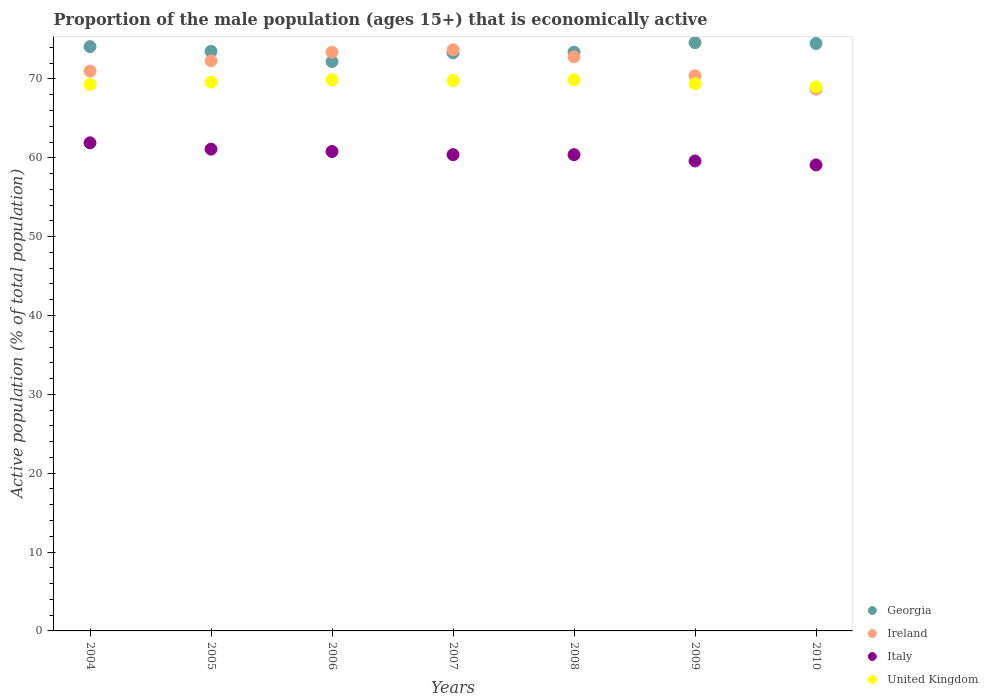How many different coloured dotlines are there?
Provide a succinct answer. 4. What is the proportion of the male population that is economically active in Italy in 2009?
Keep it short and to the point. 59.6. Across all years, what is the maximum proportion of the male population that is economically active in Italy?
Keep it short and to the point. 61.9. Across all years, what is the minimum proportion of the male population that is economically active in United Kingdom?
Offer a terse response. 69. What is the total proportion of the male population that is economically active in Italy in the graph?
Provide a short and direct response. 423.3. What is the difference between the proportion of the male population that is economically active in Georgia in 2010 and the proportion of the male population that is economically active in Ireland in 2008?
Offer a terse response. 1.7. What is the average proportion of the male population that is economically active in United Kingdom per year?
Keep it short and to the point. 69.56. In the year 2004, what is the difference between the proportion of the male population that is economically active in Ireland and proportion of the male population that is economically active in United Kingdom?
Offer a very short reply. 1.7. What is the ratio of the proportion of the male population that is economically active in United Kingdom in 2007 to that in 2008?
Make the answer very short. 1. Is the proportion of the male population that is economically active in Italy in 2005 less than that in 2009?
Ensure brevity in your answer.  No. Is the difference between the proportion of the male population that is economically active in Ireland in 2007 and 2009 greater than the difference between the proportion of the male population that is economically active in United Kingdom in 2007 and 2009?
Your answer should be compact. Yes. What is the difference between the highest and the lowest proportion of the male population that is economically active in Georgia?
Provide a succinct answer. 2.4. Is the sum of the proportion of the male population that is economically active in Georgia in 2006 and 2007 greater than the maximum proportion of the male population that is economically active in Italy across all years?
Give a very brief answer. Yes. Is it the case that in every year, the sum of the proportion of the male population that is economically active in United Kingdom and proportion of the male population that is economically active in Georgia  is greater than the sum of proportion of the male population that is economically active in Italy and proportion of the male population that is economically active in Ireland?
Your response must be concise. Yes. Is it the case that in every year, the sum of the proportion of the male population that is economically active in Ireland and proportion of the male population that is economically active in Georgia  is greater than the proportion of the male population that is economically active in Italy?
Provide a short and direct response. Yes. Does the proportion of the male population that is economically active in United Kingdom monotonically increase over the years?
Your response must be concise. No. Is the proportion of the male population that is economically active in United Kingdom strictly less than the proportion of the male population that is economically active in Ireland over the years?
Keep it short and to the point. No. Does the graph contain grids?
Provide a succinct answer. No. Where does the legend appear in the graph?
Provide a short and direct response. Bottom right. How are the legend labels stacked?
Give a very brief answer. Vertical. What is the title of the graph?
Keep it short and to the point. Proportion of the male population (ages 15+) that is economically active. What is the label or title of the X-axis?
Provide a short and direct response. Years. What is the label or title of the Y-axis?
Make the answer very short. Active population (% of total population). What is the Active population (% of total population) of Georgia in 2004?
Make the answer very short. 74.1. What is the Active population (% of total population) of Italy in 2004?
Provide a short and direct response. 61.9. What is the Active population (% of total population) in United Kingdom in 2004?
Make the answer very short. 69.3. What is the Active population (% of total population) of Georgia in 2005?
Keep it short and to the point. 73.5. What is the Active population (% of total population) of Ireland in 2005?
Your response must be concise. 72.3. What is the Active population (% of total population) of Italy in 2005?
Offer a very short reply. 61.1. What is the Active population (% of total population) of United Kingdom in 2005?
Offer a very short reply. 69.6. What is the Active population (% of total population) in Georgia in 2006?
Make the answer very short. 72.2. What is the Active population (% of total population) in Ireland in 2006?
Provide a succinct answer. 73.4. What is the Active population (% of total population) of Italy in 2006?
Give a very brief answer. 60.8. What is the Active population (% of total population) in United Kingdom in 2006?
Your answer should be compact. 69.9. What is the Active population (% of total population) in Georgia in 2007?
Your answer should be compact. 73.3. What is the Active population (% of total population) in Ireland in 2007?
Provide a succinct answer. 73.7. What is the Active population (% of total population) of Italy in 2007?
Ensure brevity in your answer.  60.4. What is the Active population (% of total population) in United Kingdom in 2007?
Your answer should be compact. 69.8. What is the Active population (% of total population) of Georgia in 2008?
Give a very brief answer. 73.4. What is the Active population (% of total population) in Ireland in 2008?
Provide a short and direct response. 72.8. What is the Active population (% of total population) of Italy in 2008?
Ensure brevity in your answer.  60.4. What is the Active population (% of total population) in United Kingdom in 2008?
Make the answer very short. 69.9. What is the Active population (% of total population) of Georgia in 2009?
Your answer should be very brief. 74.6. What is the Active population (% of total population) of Ireland in 2009?
Give a very brief answer. 70.4. What is the Active population (% of total population) in Italy in 2009?
Offer a very short reply. 59.6. What is the Active population (% of total population) in United Kingdom in 2009?
Offer a very short reply. 69.4. What is the Active population (% of total population) of Georgia in 2010?
Your response must be concise. 74.5. What is the Active population (% of total population) in Ireland in 2010?
Offer a terse response. 68.7. What is the Active population (% of total population) of Italy in 2010?
Offer a terse response. 59.1. Across all years, what is the maximum Active population (% of total population) of Georgia?
Your answer should be compact. 74.6. Across all years, what is the maximum Active population (% of total population) in Ireland?
Your answer should be compact. 73.7. Across all years, what is the maximum Active population (% of total population) in Italy?
Make the answer very short. 61.9. Across all years, what is the maximum Active population (% of total population) of United Kingdom?
Keep it short and to the point. 69.9. Across all years, what is the minimum Active population (% of total population) of Georgia?
Keep it short and to the point. 72.2. Across all years, what is the minimum Active population (% of total population) in Ireland?
Your response must be concise. 68.7. Across all years, what is the minimum Active population (% of total population) of Italy?
Ensure brevity in your answer.  59.1. What is the total Active population (% of total population) of Georgia in the graph?
Your answer should be compact. 515.6. What is the total Active population (% of total population) in Ireland in the graph?
Ensure brevity in your answer.  502.3. What is the total Active population (% of total population) in Italy in the graph?
Provide a succinct answer. 423.3. What is the total Active population (% of total population) in United Kingdom in the graph?
Ensure brevity in your answer.  486.9. What is the difference between the Active population (% of total population) of United Kingdom in 2004 and that in 2005?
Keep it short and to the point. -0.3. What is the difference between the Active population (% of total population) in Ireland in 2004 and that in 2006?
Give a very brief answer. -2.4. What is the difference between the Active population (% of total population) of Italy in 2004 and that in 2006?
Ensure brevity in your answer.  1.1. What is the difference between the Active population (% of total population) of Georgia in 2004 and that in 2007?
Provide a short and direct response. 0.8. What is the difference between the Active population (% of total population) of Ireland in 2004 and that in 2007?
Give a very brief answer. -2.7. What is the difference between the Active population (% of total population) in Italy in 2004 and that in 2007?
Provide a short and direct response. 1.5. What is the difference between the Active population (% of total population) in Italy in 2004 and that in 2008?
Provide a short and direct response. 1.5. What is the difference between the Active population (% of total population) of United Kingdom in 2004 and that in 2008?
Your answer should be very brief. -0.6. What is the difference between the Active population (% of total population) of Georgia in 2004 and that in 2009?
Offer a terse response. -0.5. What is the difference between the Active population (% of total population) of Ireland in 2004 and that in 2009?
Offer a very short reply. 0.6. What is the difference between the Active population (% of total population) in Georgia in 2004 and that in 2010?
Keep it short and to the point. -0.4. What is the difference between the Active population (% of total population) in Ireland in 2004 and that in 2010?
Keep it short and to the point. 2.3. What is the difference between the Active population (% of total population) in United Kingdom in 2004 and that in 2010?
Ensure brevity in your answer.  0.3. What is the difference between the Active population (% of total population) in Georgia in 2005 and that in 2006?
Ensure brevity in your answer.  1.3. What is the difference between the Active population (% of total population) in Italy in 2005 and that in 2006?
Your answer should be very brief. 0.3. What is the difference between the Active population (% of total population) of Georgia in 2005 and that in 2007?
Provide a succinct answer. 0.2. What is the difference between the Active population (% of total population) of Ireland in 2005 and that in 2007?
Keep it short and to the point. -1.4. What is the difference between the Active population (% of total population) in Italy in 2005 and that in 2007?
Provide a short and direct response. 0.7. What is the difference between the Active population (% of total population) in Georgia in 2005 and that in 2008?
Keep it short and to the point. 0.1. What is the difference between the Active population (% of total population) of Ireland in 2005 and that in 2008?
Ensure brevity in your answer.  -0.5. What is the difference between the Active population (% of total population) of United Kingdom in 2005 and that in 2008?
Provide a succinct answer. -0.3. What is the difference between the Active population (% of total population) of United Kingdom in 2005 and that in 2009?
Ensure brevity in your answer.  0.2. What is the difference between the Active population (% of total population) of Georgia in 2005 and that in 2010?
Give a very brief answer. -1. What is the difference between the Active population (% of total population) in Georgia in 2006 and that in 2007?
Provide a succinct answer. -1.1. What is the difference between the Active population (% of total population) of Ireland in 2006 and that in 2007?
Offer a terse response. -0.3. What is the difference between the Active population (% of total population) in Italy in 2006 and that in 2007?
Offer a terse response. 0.4. What is the difference between the Active population (% of total population) in Georgia in 2006 and that in 2008?
Provide a succinct answer. -1.2. What is the difference between the Active population (% of total population) in Ireland in 2006 and that in 2008?
Provide a succinct answer. 0.6. What is the difference between the Active population (% of total population) in Ireland in 2006 and that in 2009?
Offer a terse response. 3. What is the difference between the Active population (% of total population) in Italy in 2006 and that in 2009?
Your answer should be compact. 1.2. What is the difference between the Active population (% of total population) in Ireland in 2006 and that in 2010?
Offer a terse response. 4.7. What is the difference between the Active population (% of total population) in Italy in 2007 and that in 2008?
Provide a short and direct response. 0. What is the difference between the Active population (% of total population) in Ireland in 2007 and that in 2009?
Make the answer very short. 3.3. What is the difference between the Active population (% of total population) in Italy in 2007 and that in 2009?
Your response must be concise. 0.8. What is the difference between the Active population (% of total population) of United Kingdom in 2007 and that in 2009?
Keep it short and to the point. 0.4. What is the difference between the Active population (% of total population) in Ireland in 2007 and that in 2010?
Your answer should be very brief. 5. What is the difference between the Active population (% of total population) in Italy in 2007 and that in 2010?
Keep it short and to the point. 1.3. What is the difference between the Active population (% of total population) in Georgia in 2008 and that in 2009?
Keep it short and to the point. -1.2. What is the difference between the Active population (% of total population) of Italy in 2008 and that in 2009?
Your answer should be compact. 0.8. What is the difference between the Active population (% of total population) of United Kingdom in 2008 and that in 2009?
Give a very brief answer. 0.5. What is the difference between the Active population (% of total population) of Georgia in 2008 and that in 2010?
Provide a short and direct response. -1.1. What is the difference between the Active population (% of total population) of Italy in 2008 and that in 2010?
Your answer should be very brief. 1.3. What is the difference between the Active population (% of total population) in Ireland in 2009 and that in 2010?
Keep it short and to the point. 1.7. What is the difference between the Active population (% of total population) in Georgia in 2004 and the Active population (% of total population) in Italy in 2005?
Your answer should be very brief. 13. What is the difference between the Active population (% of total population) of Ireland in 2004 and the Active population (% of total population) of Italy in 2005?
Make the answer very short. 9.9. What is the difference between the Active population (% of total population) in Italy in 2004 and the Active population (% of total population) in United Kingdom in 2005?
Give a very brief answer. -7.7. What is the difference between the Active population (% of total population) in Georgia in 2004 and the Active population (% of total population) in United Kingdom in 2006?
Your answer should be very brief. 4.2. What is the difference between the Active population (% of total population) in Georgia in 2004 and the Active population (% of total population) in Ireland in 2007?
Make the answer very short. 0.4. What is the difference between the Active population (% of total population) of Georgia in 2004 and the Active population (% of total population) of Italy in 2007?
Your response must be concise. 13.7. What is the difference between the Active population (% of total population) in Ireland in 2004 and the Active population (% of total population) in Italy in 2007?
Provide a succinct answer. 10.6. What is the difference between the Active population (% of total population) in Italy in 2004 and the Active population (% of total population) in United Kingdom in 2007?
Keep it short and to the point. -7.9. What is the difference between the Active population (% of total population) in Georgia in 2004 and the Active population (% of total population) in Italy in 2008?
Provide a short and direct response. 13.7. What is the difference between the Active population (% of total population) of Georgia in 2004 and the Active population (% of total population) of United Kingdom in 2008?
Keep it short and to the point. 4.2. What is the difference between the Active population (% of total population) in Ireland in 2004 and the Active population (% of total population) in United Kingdom in 2008?
Make the answer very short. 1.1. What is the difference between the Active population (% of total population) of Georgia in 2004 and the Active population (% of total population) of Italy in 2009?
Offer a terse response. 14.5. What is the difference between the Active population (% of total population) of Italy in 2004 and the Active population (% of total population) of United Kingdom in 2009?
Provide a succinct answer. -7.5. What is the difference between the Active population (% of total population) of Georgia in 2004 and the Active population (% of total population) of United Kingdom in 2010?
Provide a short and direct response. 5.1. What is the difference between the Active population (% of total population) of Ireland in 2004 and the Active population (% of total population) of Italy in 2010?
Ensure brevity in your answer.  11.9. What is the difference between the Active population (% of total population) of Ireland in 2004 and the Active population (% of total population) of United Kingdom in 2010?
Offer a terse response. 2. What is the difference between the Active population (% of total population) in Ireland in 2005 and the Active population (% of total population) in Italy in 2006?
Ensure brevity in your answer.  11.5. What is the difference between the Active population (% of total population) in Ireland in 2005 and the Active population (% of total population) in United Kingdom in 2006?
Provide a succinct answer. 2.4. What is the difference between the Active population (% of total population) of Georgia in 2005 and the Active population (% of total population) of Italy in 2007?
Give a very brief answer. 13.1. What is the difference between the Active population (% of total population) of Ireland in 2005 and the Active population (% of total population) of Italy in 2007?
Ensure brevity in your answer.  11.9. What is the difference between the Active population (% of total population) of Italy in 2005 and the Active population (% of total population) of United Kingdom in 2007?
Keep it short and to the point. -8.7. What is the difference between the Active population (% of total population) in Georgia in 2005 and the Active population (% of total population) in Ireland in 2008?
Your answer should be very brief. 0.7. What is the difference between the Active population (% of total population) in Georgia in 2005 and the Active population (% of total population) in Italy in 2008?
Offer a very short reply. 13.1. What is the difference between the Active population (% of total population) of Georgia in 2005 and the Active population (% of total population) of United Kingdom in 2008?
Provide a succinct answer. 3.6. What is the difference between the Active population (% of total population) of Ireland in 2005 and the Active population (% of total population) of Italy in 2008?
Keep it short and to the point. 11.9. What is the difference between the Active population (% of total population) of Ireland in 2005 and the Active population (% of total population) of Italy in 2009?
Give a very brief answer. 12.7. What is the difference between the Active population (% of total population) in Ireland in 2005 and the Active population (% of total population) in United Kingdom in 2009?
Provide a succinct answer. 2.9. What is the difference between the Active population (% of total population) of Italy in 2005 and the Active population (% of total population) of United Kingdom in 2009?
Your answer should be very brief. -8.3. What is the difference between the Active population (% of total population) of Georgia in 2005 and the Active population (% of total population) of Ireland in 2010?
Keep it short and to the point. 4.8. What is the difference between the Active population (% of total population) of Ireland in 2005 and the Active population (% of total population) of Italy in 2010?
Your response must be concise. 13.2. What is the difference between the Active population (% of total population) in Italy in 2005 and the Active population (% of total population) in United Kingdom in 2010?
Provide a succinct answer. -7.9. What is the difference between the Active population (% of total population) in Georgia in 2006 and the Active population (% of total population) in Italy in 2007?
Offer a terse response. 11.8. What is the difference between the Active population (% of total population) in Ireland in 2006 and the Active population (% of total population) in Italy in 2007?
Offer a very short reply. 13. What is the difference between the Active population (% of total population) of Ireland in 2006 and the Active population (% of total population) of United Kingdom in 2007?
Provide a short and direct response. 3.6. What is the difference between the Active population (% of total population) in Georgia in 2006 and the Active population (% of total population) in Italy in 2008?
Your answer should be very brief. 11.8. What is the difference between the Active population (% of total population) in Georgia in 2006 and the Active population (% of total population) in United Kingdom in 2008?
Offer a very short reply. 2.3. What is the difference between the Active population (% of total population) of Ireland in 2006 and the Active population (% of total population) of United Kingdom in 2008?
Offer a very short reply. 3.5. What is the difference between the Active population (% of total population) in Italy in 2006 and the Active population (% of total population) in United Kingdom in 2009?
Keep it short and to the point. -8.6. What is the difference between the Active population (% of total population) in Ireland in 2006 and the Active population (% of total population) in United Kingdom in 2010?
Make the answer very short. 4.4. What is the difference between the Active population (% of total population) in Italy in 2006 and the Active population (% of total population) in United Kingdom in 2010?
Your response must be concise. -8.2. What is the difference between the Active population (% of total population) in Georgia in 2007 and the Active population (% of total population) in Ireland in 2008?
Make the answer very short. 0.5. What is the difference between the Active population (% of total population) in Georgia in 2007 and the Active population (% of total population) in United Kingdom in 2009?
Offer a terse response. 3.9. What is the difference between the Active population (% of total population) of Ireland in 2007 and the Active population (% of total population) of United Kingdom in 2009?
Make the answer very short. 4.3. What is the difference between the Active population (% of total population) of Italy in 2007 and the Active population (% of total population) of United Kingdom in 2009?
Provide a succinct answer. -9. What is the difference between the Active population (% of total population) of Georgia in 2007 and the Active population (% of total population) of Ireland in 2010?
Ensure brevity in your answer.  4.6. What is the difference between the Active population (% of total population) in Ireland in 2007 and the Active population (% of total population) in Italy in 2010?
Give a very brief answer. 14.6. What is the difference between the Active population (% of total population) in Italy in 2007 and the Active population (% of total population) in United Kingdom in 2010?
Provide a succinct answer. -8.6. What is the difference between the Active population (% of total population) in Georgia in 2008 and the Active population (% of total population) in United Kingdom in 2009?
Offer a terse response. 4. What is the difference between the Active population (% of total population) in Italy in 2008 and the Active population (% of total population) in United Kingdom in 2009?
Your response must be concise. -9. What is the difference between the Active population (% of total population) in Georgia in 2008 and the Active population (% of total population) in Italy in 2010?
Offer a very short reply. 14.3. What is the difference between the Active population (% of total population) of Ireland in 2008 and the Active population (% of total population) of United Kingdom in 2010?
Your answer should be compact. 3.8. What is the difference between the Active population (% of total population) of Italy in 2008 and the Active population (% of total population) of United Kingdom in 2010?
Your answer should be compact. -8.6. What is the difference between the Active population (% of total population) of Georgia in 2009 and the Active population (% of total population) of Italy in 2010?
Provide a short and direct response. 15.5. What is the difference between the Active population (% of total population) of Georgia in 2009 and the Active population (% of total population) of United Kingdom in 2010?
Your answer should be very brief. 5.6. What is the difference between the Active population (% of total population) of Ireland in 2009 and the Active population (% of total population) of Italy in 2010?
Make the answer very short. 11.3. What is the average Active population (% of total population) in Georgia per year?
Offer a terse response. 73.66. What is the average Active population (% of total population) in Ireland per year?
Offer a very short reply. 71.76. What is the average Active population (% of total population) of Italy per year?
Provide a succinct answer. 60.47. What is the average Active population (% of total population) in United Kingdom per year?
Provide a short and direct response. 69.56. In the year 2004, what is the difference between the Active population (% of total population) of Georgia and Active population (% of total population) of Italy?
Give a very brief answer. 12.2. In the year 2004, what is the difference between the Active population (% of total population) of Ireland and Active population (% of total population) of Italy?
Your answer should be very brief. 9.1. In the year 2004, what is the difference between the Active population (% of total population) of Ireland and Active population (% of total population) of United Kingdom?
Provide a succinct answer. 1.7. In the year 2005, what is the difference between the Active population (% of total population) in Georgia and Active population (% of total population) in Italy?
Provide a short and direct response. 12.4. In the year 2005, what is the difference between the Active population (% of total population) of Georgia and Active population (% of total population) of United Kingdom?
Offer a terse response. 3.9. In the year 2005, what is the difference between the Active population (% of total population) of Ireland and Active population (% of total population) of Italy?
Provide a succinct answer. 11.2. In the year 2005, what is the difference between the Active population (% of total population) in Ireland and Active population (% of total population) in United Kingdom?
Your answer should be very brief. 2.7. In the year 2005, what is the difference between the Active population (% of total population) in Italy and Active population (% of total population) in United Kingdom?
Provide a succinct answer. -8.5. In the year 2006, what is the difference between the Active population (% of total population) in Ireland and Active population (% of total population) in Italy?
Provide a succinct answer. 12.6. In the year 2007, what is the difference between the Active population (% of total population) in Georgia and Active population (% of total population) in Ireland?
Offer a terse response. -0.4. In the year 2007, what is the difference between the Active population (% of total population) of Georgia and Active population (% of total population) of Italy?
Your answer should be very brief. 12.9. In the year 2007, what is the difference between the Active population (% of total population) in Georgia and Active population (% of total population) in United Kingdom?
Give a very brief answer. 3.5. In the year 2007, what is the difference between the Active population (% of total population) of Ireland and Active population (% of total population) of Italy?
Your answer should be very brief. 13.3. In the year 2007, what is the difference between the Active population (% of total population) of Italy and Active population (% of total population) of United Kingdom?
Your answer should be very brief. -9.4. In the year 2008, what is the difference between the Active population (% of total population) in Georgia and Active population (% of total population) in Italy?
Offer a terse response. 13. In the year 2008, what is the difference between the Active population (% of total population) of Ireland and Active population (% of total population) of Italy?
Give a very brief answer. 12.4. In the year 2008, what is the difference between the Active population (% of total population) of Ireland and Active population (% of total population) of United Kingdom?
Ensure brevity in your answer.  2.9. In the year 2008, what is the difference between the Active population (% of total population) in Italy and Active population (% of total population) in United Kingdom?
Ensure brevity in your answer.  -9.5. In the year 2009, what is the difference between the Active population (% of total population) of Georgia and Active population (% of total population) of Ireland?
Offer a terse response. 4.2. In the year 2009, what is the difference between the Active population (% of total population) of Georgia and Active population (% of total population) of Italy?
Offer a terse response. 15. In the year 2009, what is the difference between the Active population (% of total population) of Georgia and Active population (% of total population) of United Kingdom?
Offer a terse response. 5.2. In the year 2010, what is the difference between the Active population (% of total population) of Georgia and Active population (% of total population) of Italy?
Your answer should be compact. 15.4. In the year 2010, what is the difference between the Active population (% of total population) of Ireland and Active population (% of total population) of United Kingdom?
Make the answer very short. -0.3. What is the ratio of the Active population (% of total population) in Georgia in 2004 to that in 2005?
Give a very brief answer. 1.01. What is the ratio of the Active population (% of total population) of Ireland in 2004 to that in 2005?
Provide a short and direct response. 0.98. What is the ratio of the Active population (% of total population) in Italy in 2004 to that in 2005?
Your answer should be very brief. 1.01. What is the ratio of the Active population (% of total population) of Georgia in 2004 to that in 2006?
Provide a short and direct response. 1.03. What is the ratio of the Active population (% of total population) of Ireland in 2004 to that in 2006?
Offer a very short reply. 0.97. What is the ratio of the Active population (% of total population) of Italy in 2004 to that in 2006?
Your response must be concise. 1.02. What is the ratio of the Active population (% of total population) of United Kingdom in 2004 to that in 2006?
Ensure brevity in your answer.  0.99. What is the ratio of the Active population (% of total population) in Georgia in 2004 to that in 2007?
Provide a succinct answer. 1.01. What is the ratio of the Active population (% of total population) in Ireland in 2004 to that in 2007?
Ensure brevity in your answer.  0.96. What is the ratio of the Active population (% of total population) of Italy in 2004 to that in 2007?
Make the answer very short. 1.02. What is the ratio of the Active population (% of total population) in United Kingdom in 2004 to that in 2007?
Provide a succinct answer. 0.99. What is the ratio of the Active population (% of total population) in Georgia in 2004 to that in 2008?
Provide a short and direct response. 1.01. What is the ratio of the Active population (% of total population) in Ireland in 2004 to that in 2008?
Offer a very short reply. 0.98. What is the ratio of the Active population (% of total population) in Italy in 2004 to that in 2008?
Provide a succinct answer. 1.02. What is the ratio of the Active population (% of total population) of United Kingdom in 2004 to that in 2008?
Provide a short and direct response. 0.99. What is the ratio of the Active population (% of total population) of Ireland in 2004 to that in 2009?
Your answer should be compact. 1.01. What is the ratio of the Active population (% of total population) of Italy in 2004 to that in 2009?
Offer a very short reply. 1.04. What is the ratio of the Active population (% of total population) in Ireland in 2004 to that in 2010?
Your response must be concise. 1.03. What is the ratio of the Active population (% of total population) of Italy in 2004 to that in 2010?
Ensure brevity in your answer.  1.05. What is the ratio of the Active population (% of total population) in Georgia in 2005 to that in 2006?
Give a very brief answer. 1.02. What is the ratio of the Active population (% of total population) of Ireland in 2005 to that in 2006?
Offer a terse response. 0.98. What is the ratio of the Active population (% of total population) of Italy in 2005 to that in 2006?
Your response must be concise. 1. What is the ratio of the Active population (% of total population) in Ireland in 2005 to that in 2007?
Provide a succinct answer. 0.98. What is the ratio of the Active population (% of total population) of Italy in 2005 to that in 2007?
Offer a terse response. 1.01. What is the ratio of the Active population (% of total population) of United Kingdom in 2005 to that in 2007?
Make the answer very short. 1. What is the ratio of the Active population (% of total population) in Georgia in 2005 to that in 2008?
Your response must be concise. 1. What is the ratio of the Active population (% of total population) of Ireland in 2005 to that in 2008?
Provide a short and direct response. 0.99. What is the ratio of the Active population (% of total population) of Italy in 2005 to that in 2008?
Give a very brief answer. 1.01. What is the ratio of the Active population (% of total population) in United Kingdom in 2005 to that in 2008?
Your answer should be compact. 1. What is the ratio of the Active population (% of total population) in Georgia in 2005 to that in 2009?
Your answer should be very brief. 0.99. What is the ratio of the Active population (% of total population) in Ireland in 2005 to that in 2009?
Give a very brief answer. 1.03. What is the ratio of the Active population (% of total population) in Italy in 2005 to that in 2009?
Your answer should be very brief. 1.03. What is the ratio of the Active population (% of total population) of United Kingdom in 2005 to that in 2009?
Your answer should be very brief. 1. What is the ratio of the Active population (% of total population) in Georgia in 2005 to that in 2010?
Your answer should be compact. 0.99. What is the ratio of the Active population (% of total population) in Ireland in 2005 to that in 2010?
Offer a very short reply. 1.05. What is the ratio of the Active population (% of total population) in Italy in 2005 to that in 2010?
Your answer should be very brief. 1.03. What is the ratio of the Active population (% of total population) of United Kingdom in 2005 to that in 2010?
Offer a terse response. 1.01. What is the ratio of the Active population (% of total population) in Georgia in 2006 to that in 2007?
Make the answer very short. 0.98. What is the ratio of the Active population (% of total population) of Italy in 2006 to that in 2007?
Make the answer very short. 1.01. What is the ratio of the Active population (% of total population) of Georgia in 2006 to that in 2008?
Give a very brief answer. 0.98. What is the ratio of the Active population (% of total population) in Ireland in 2006 to that in 2008?
Keep it short and to the point. 1.01. What is the ratio of the Active population (% of total population) of Italy in 2006 to that in 2008?
Your answer should be very brief. 1.01. What is the ratio of the Active population (% of total population) in United Kingdom in 2006 to that in 2008?
Offer a terse response. 1. What is the ratio of the Active population (% of total population) in Georgia in 2006 to that in 2009?
Offer a very short reply. 0.97. What is the ratio of the Active population (% of total population) of Ireland in 2006 to that in 2009?
Offer a terse response. 1.04. What is the ratio of the Active population (% of total population) in Italy in 2006 to that in 2009?
Your response must be concise. 1.02. What is the ratio of the Active population (% of total population) of Georgia in 2006 to that in 2010?
Your answer should be compact. 0.97. What is the ratio of the Active population (% of total population) of Ireland in 2006 to that in 2010?
Make the answer very short. 1.07. What is the ratio of the Active population (% of total population) in Italy in 2006 to that in 2010?
Offer a very short reply. 1.03. What is the ratio of the Active population (% of total population) in United Kingdom in 2006 to that in 2010?
Keep it short and to the point. 1.01. What is the ratio of the Active population (% of total population) in Georgia in 2007 to that in 2008?
Offer a terse response. 1. What is the ratio of the Active population (% of total population) in Ireland in 2007 to that in 2008?
Provide a short and direct response. 1.01. What is the ratio of the Active population (% of total population) in Italy in 2007 to that in 2008?
Keep it short and to the point. 1. What is the ratio of the Active population (% of total population) in Georgia in 2007 to that in 2009?
Keep it short and to the point. 0.98. What is the ratio of the Active population (% of total population) in Ireland in 2007 to that in 2009?
Give a very brief answer. 1.05. What is the ratio of the Active population (% of total population) in Italy in 2007 to that in 2009?
Give a very brief answer. 1.01. What is the ratio of the Active population (% of total population) in United Kingdom in 2007 to that in 2009?
Provide a short and direct response. 1.01. What is the ratio of the Active population (% of total population) in Georgia in 2007 to that in 2010?
Your response must be concise. 0.98. What is the ratio of the Active population (% of total population) of Ireland in 2007 to that in 2010?
Ensure brevity in your answer.  1.07. What is the ratio of the Active population (% of total population) of Italy in 2007 to that in 2010?
Ensure brevity in your answer.  1.02. What is the ratio of the Active population (% of total population) in United Kingdom in 2007 to that in 2010?
Your answer should be compact. 1.01. What is the ratio of the Active population (% of total population) in Georgia in 2008 to that in 2009?
Your answer should be compact. 0.98. What is the ratio of the Active population (% of total population) in Ireland in 2008 to that in 2009?
Ensure brevity in your answer.  1.03. What is the ratio of the Active population (% of total population) of Italy in 2008 to that in 2009?
Offer a very short reply. 1.01. What is the ratio of the Active population (% of total population) of Georgia in 2008 to that in 2010?
Your response must be concise. 0.99. What is the ratio of the Active population (% of total population) of Ireland in 2008 to that in 2010?
Offer a very short reply. 1.06. What is the ratio of the Active population (% of total population) of United Kingdom in 2008 to that in 2010?
Ensure brevity in your answer.  1.01. What is the ratio of the Active population (% of total population) of Ireland in 2009 to that in 2010?
Ensure brevity in your answer.  1.02. What is the ratio of the Active population (% of total population) in Italy in 2009 to that in 2010?
Make the answer very short. 1.01. What is the ratio of the Active population (% of total population) of United Kingdom in 2009 to that in 2010?
Provide a succinct answer. 1.01. What is the difference between the highest and the second highest Active population (% of total population) of Ireland?
Provide a short and direct response. 0.3. What is the difference between the highest and the second highest Active population (% of total population) of Italy?
Provide a short and direct response. 0.8. What is the difference between the highest and the second highest Active population (% of total population) in United Kingdom?
Offer a terse response. 0. What is the difference between the highest and the lowest Active population (% of total population) in Ireland?
Keep it short and to the point. 5. What is the difference between the highest and the lowest Active population (% of total population) in Italy?
Make the answer very short. 2.8. 